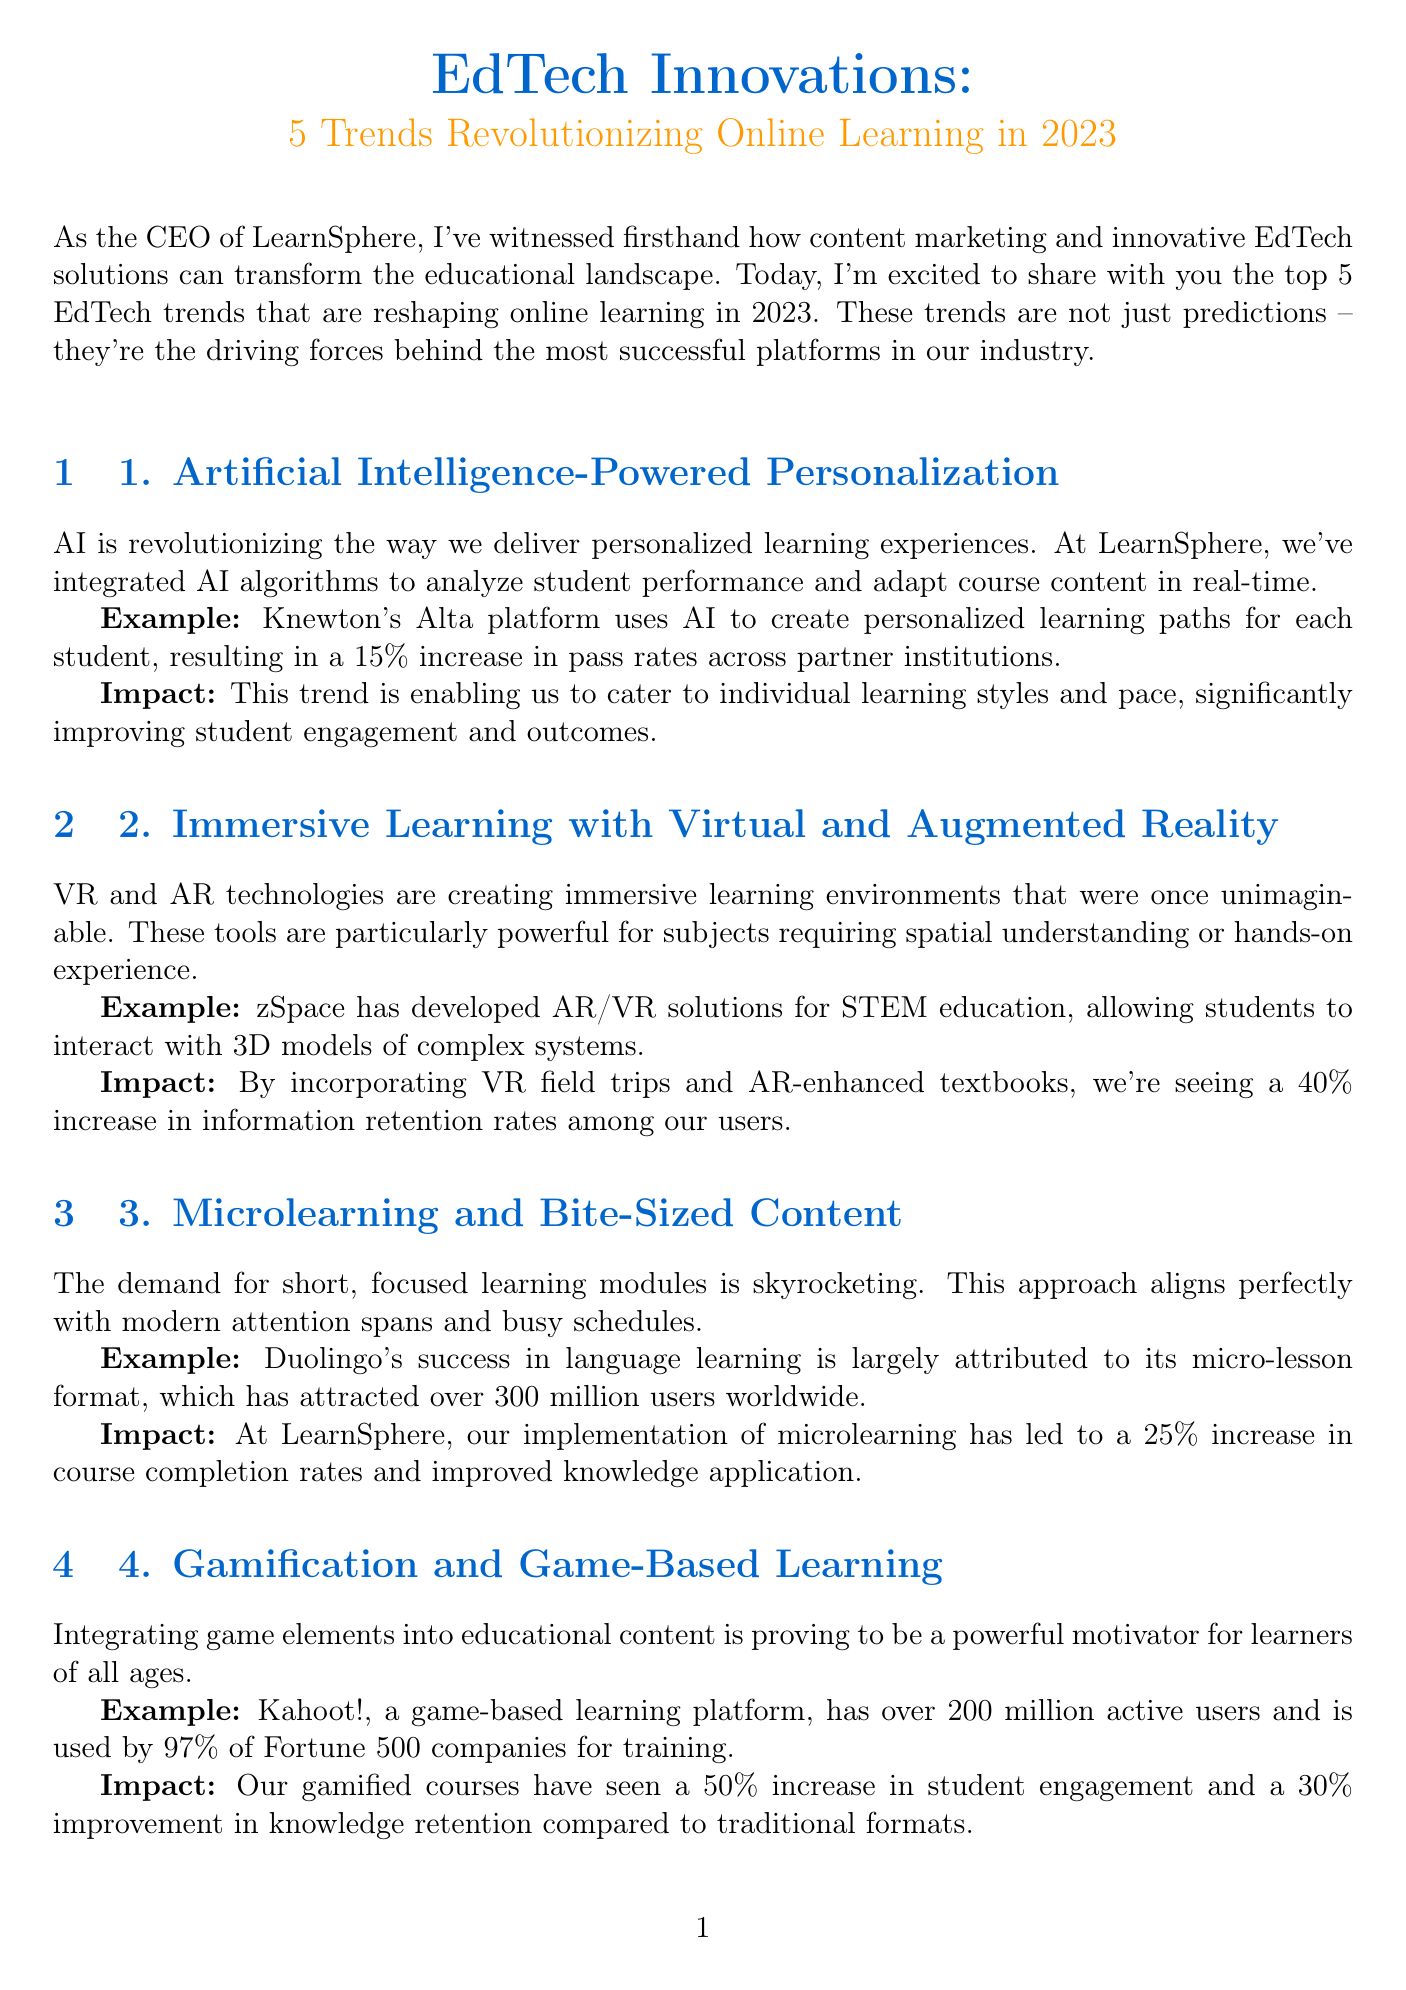what is the title of the newsletter? The title of the newsletter is specified in the document, calling attention to the topic of EdTech innovations.
Answer: EdTech Innovations: 5 Trends Revolutionizing Online Learning in 2023 what is the first trend mentioned? The first trend is discussed in detail in the document, focusing on the impact of AI on learning.
Answer: Artificial Intelligence-Powered Personalization how much did Knewton's Alta platform increase pass rates? The document provides a specific percentage increase resulting from the use of Knewton's platform.
Answer: 15% what is the impact of gamified courses mentioned in the document? The document highlights the improvement in student engagement and knowledge retention due to gamification.
Answer: 50% increase in engagement which company has been issuing digital diplomas since 2017? The newsletter mentions a prestigious institution known for its innovative use of blockchain technology for credentials.
Answer: MIT what is a key benefit of microlearning according to the document? The document emphasizes the effectiveness of short learning modules in terms of course completion rates.
Answer: 25% increase in course completion rates what technology is revolutionizing secure credentialing? The document identifies the specific technology making a significant change in the way educational credentials are handled.
Answer: Blockchain which platform is mentioned as an example for gamification? The newsletter provides an example of a popular platform that uses game-based learning techniques effectively.
Answer: Kahoot! 